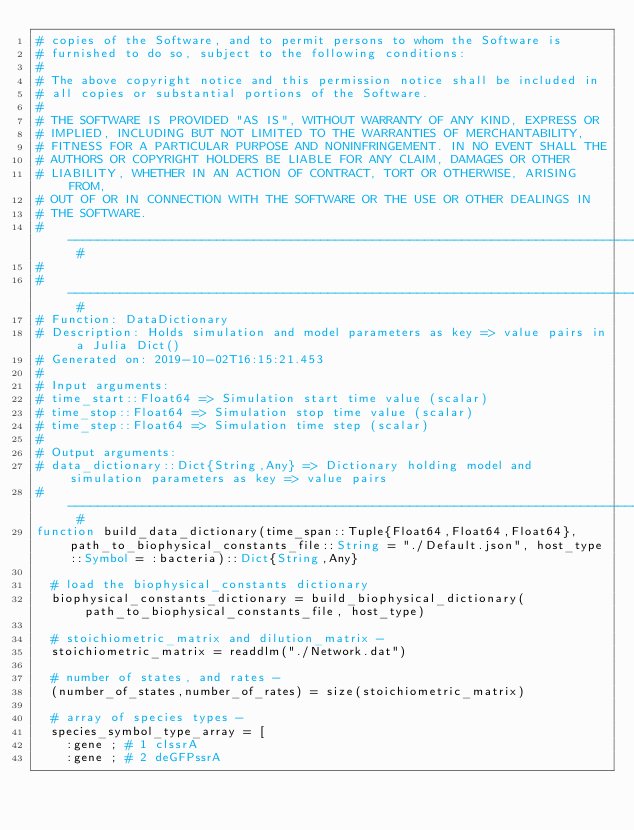<code> <loc_0><loc_0><loc_500><loc_500><_Julia_># copies of the Software, and to permit persons to whom the Software is
# furnished to do so, subject to the following conditions:
#
# The above copyright notice and this permission notice shall be included in
# all copies or substantial portions of the Software.
#
# THE SOFTWARE IS PROVIDED "AS IS", WITHOUT WARRANTY OF ANY KIND, EXPRESS OR
# IMPLIED, INCLUDING BUT NOT LIMITED TO THE WARRANTIES OF MERCHANTABILITY,
# FITNESS FOR A PARTICULAR PURPOSE AND NONINFRINGEMENT. IN NO EVENT SHALL THE
# AUTHORS OR COPYRIGHT HOLDERS BE LIABLE FOR ANY CLAIM, DAMAGES OR OTHER
# LIABILITY, WHETHER IN AN ACTION OF CONTRACT, TORT OR OTHERWISE, ARISING FROM,
# OUT OF OR IN CONNECTION WITH THE SOFTWARE OR THE USE OR OTHER DEALINGS IN
# THE SOFTWARE.
# ----------------------------------------------------------------------------------- #
#
# ----------------------------------------------------------------------------------- #
# Function: DataDictionary
# Description: Holds simulation and model parameters as key => value pairs in a Julia Dict()
# Generated on: 2019-10-02T16:15:21.453
#
# Input arguments:
# time_start::Float64 => Simulation start time value (scalar)
# time_stop::Float64 => Simulation stop time value (scalar)
# time_step::Float64 => Simulation time step (scalar)
#
# Output arguments:
# data_dictionary::Dict{String,Any} => Dictionary holding model and simulation parameters as key => value pairs
# ----------------------------------------------------------------------------------- #
function build_data_dictionary(time_span::Tuple{Float64,Float64,Float64}, path_to_biophysical_constants_file::String = "./Default.json", host_type::Symbol = :bacteria)::Dict{String,Any}

	# load the biophysical_constants dictionary
	biophysical_constants_dictionary = build_biophysical_dictionary(path_to_biophysical_constants_file, host_type)

	# stoichiometric_matrix and dilution_matrix -
	stoichiometric_matrix = readdlm("./Network.dat")

	# number of states, and rates -
	(number_of_states,number_of_rates) = size(stoichiometric_matrix)

	# array of species types -
	species_symbol_type_array = [
		:gene	;	# 1	clssrA
		:gene	;	# 2	deGFPssrA</code> 